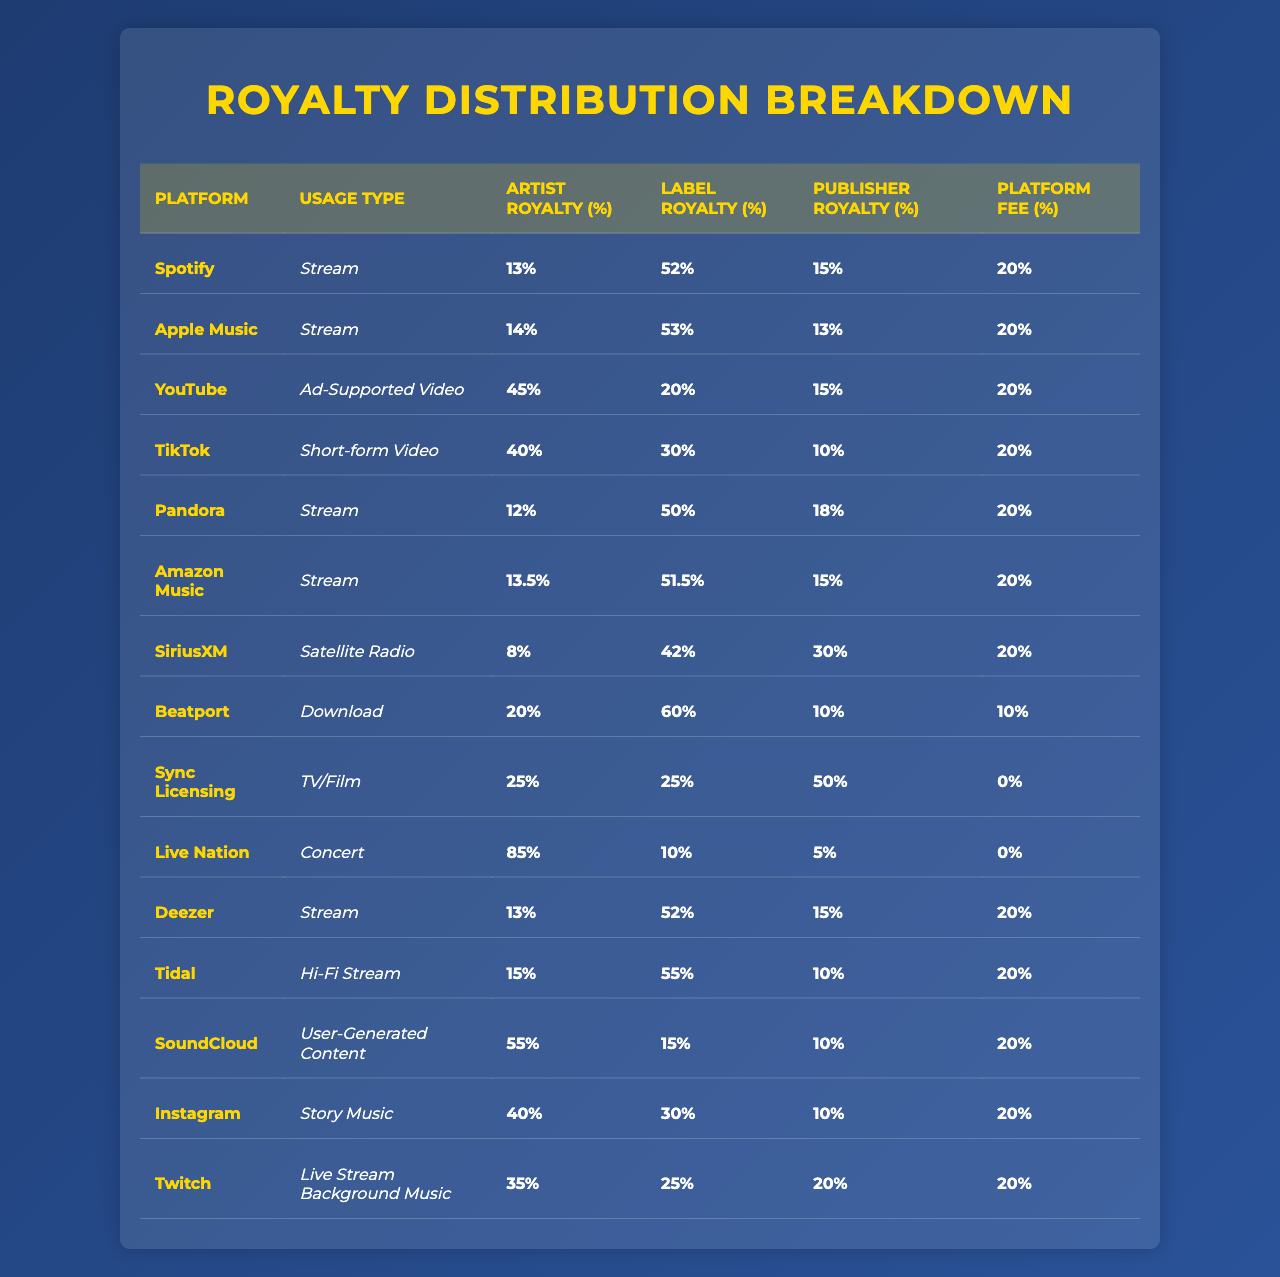What is the artist royalty percentage for Apple Music? According to the table, the artist royalty percentage specifically for Apple Music is listed under the "Artist Royalty (%)" column, which shows 14%.
Answer: 14% Which platform offers the highest artist royalty for concert usage? The table indicates that Live Nation has the highest artist royalty for concert usage, at 85%.
Answer: 85% What is the platform fee percentage for Sync Licensing in TV/Film usage? From the table, the platform fee for Sync Licensing is noted in the last column, which shows 0%.
Answer: 0% How much percentage does the label receive from TikTok compared to Spotify? For TikTok, the label receives 30% while Spotify gives the label 52%. The difference can be calculated as 52% - 30% = 22%.
Answer: 22% Is the publisher royalty for YouTube higher than that for TikTok? The publisher royalty for YouTube is 15%, and for TikTok, it is 10%. Since 15% is greater than 10%, the statement is true.
Answer: Yes What is the average artist royalty percentage across all streaming platforms? The streaming platforms listed are Spotify, Apple Music, Pandora, Amazon Music, Deezer, and Tidal. Their artist royalties are 13, 14, 12, 13.5, 13, and 15 respectively. Therefore, the average is calculated as (13 + 14 + 12 + 13.5 + 13 + 15) / 6 = 13.25%.
Answer: 13.25% For which usage type does the publisher receive the highest percentage, and what is that percentage? According to the table, for Sync Licensing in TV/Film, the publisher receives 50%, which is the highest percentage listed compared to others.
Answer: 50% What is the total royalty percentage (artist, label, publisher) for a stream on Pandora? For Pandora, the artist gets 12%, the label gets 50%, and the publisher receives 18%. The total can be calculated as 12% + 50% + 18% = 80%.
Answer: 80% Does SoundCloud provide a higher artist royalty than Apple Music? SoundCloud grants an artist royalty of 55% and Apple Music grants 14%. Since 55% is greater than 14%, the statement is true.
Answer: Yes What is the difference between the label royalties for Beatport and SiriusXM? According to the table, Beatport offers a label royalty of 60% while SiriusXM has a label royalty of 42%. The difference is calculated as 60% - 42% = 18%.
Answer: 18% 